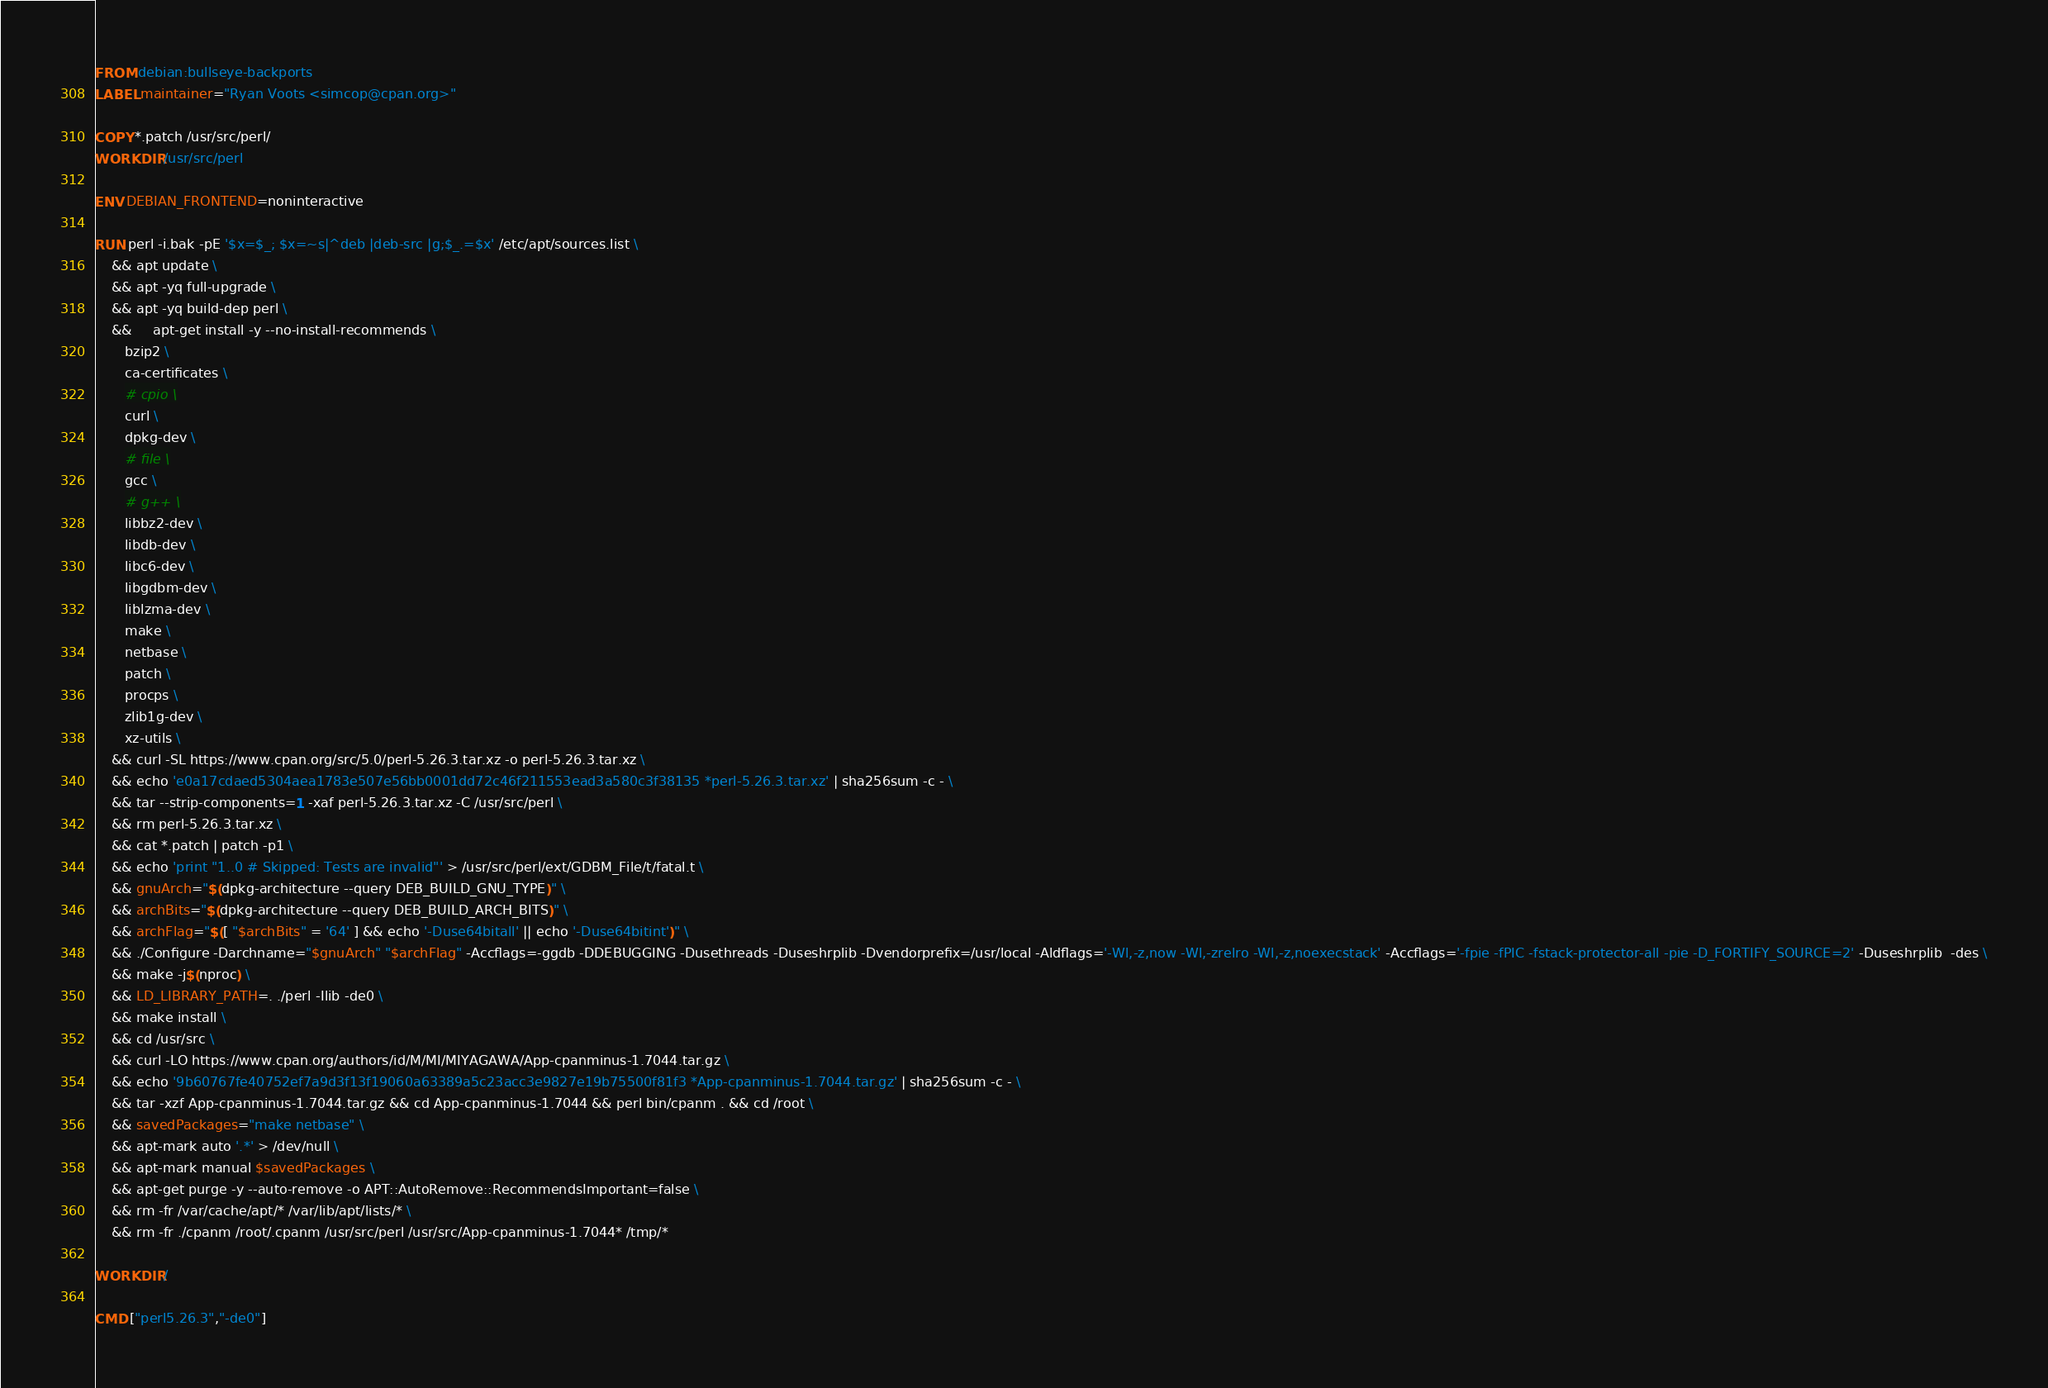<code> <loc_0><loc_0><loc_500><loc_500><_Dockerfile_>FROM debian:bullseye-backports
LABEL maintainer="Ryan Voots <simcop@cpan.org>"

COPY *.patch /usr/src/perl/
WORKDIR /usr/src/perl

ENV DEBIAN_FRONTEND=noninteractive

RUN perl -i.bak -pE '$x=$_; $x=~s|^deb |deb-src |g;$_.=$x' /etc/apt/sources.list \
    && apt update \
    && apt -yq full-upgrade \
    && apt -yq build-dep perl \
    &&     apt-get install -y --no-install-recommends \
       bzip2 \
       ca-certificates \
       # cpio \
       curl \
       dpkg-dev \
       # file \
       gcc \
       # g++ \
       libbz2-dev \
       libdb-dev \
       libc6-dev \
       libgdbm-dev \
       liblzma-dev \
       make \
       netbase \
       patch \
       procps \
       zlib1g-dev \
       xz-utils \
    && curl -SL https://www.cpan.org/src/5.0/perl-5.26.3.tar.xz -o perl-5.26.3.tar.xz \
    && echo 'e0a17cdaed5304aea1783e507e56bb0001dd72c46f211553ead3a580c3f38135 *perl-5.26.3.tar.xz' | sha256sum -c - \
    && tar --strip-components=1 -xaf perl-5.26.3.tar.xz -C /usr/src/perl \
    && rm perl-5.26.3.tar.xz \
    && cat *.patch | patch -p1 \
    && echo 'print "1..0 # Skipped: Tests are invalid"' > /usr/src/perl/ext/GDBM_File/t/fatal.t \
    && gnuArch="$(dpkg-architecture --query DEB_BUILD_GNU_TYPE)" \
    && archBits="$(dpkg-architecture --query DEB_BUILD_ARCH_BITS)" \
    && archFlag="$([ "$archBits" = '64' ] && echo '-Duse64bitall' || echo '-Duse64bitint')" \
    && ./Configure -Darchname="$gnuArch" "$archFlag" -Accflags=-ggdb -DDEBUGGING -Dusethreads -Duseshrplib -Dvendorprefix=/usr/local -Aldflags='-Wl,-z,now -Wl,-zrelro -Wl,-z,noexecstack' -Accflags='-fpie -fPIC -fstack-protector-all -pie -D_FORTIFY_SOURCE=2' -Duseshrplib  -des \
    && make -j$(nproc) \
    && LD_LIBRARY_PATH=. ./perl -Ilib -de0 \
    && make install \
    && cd /usr/src \
    && curl -LO https://www.cpan.org/authors/id/M/MI/MIYAGAWA/App-cpanminus-1.7044.tar.gz \
    && echo '9b60767fe40752ef7a9d3f13f19060a63389a5c23acc3e9827e19b75500f81f3 *App-cpanminus-1.7044.tar.gz' | sha256sum -c - \
    && tar -xzf App-cpanminus-1.7044.tar.gz && cd App-cpanminus-1.7044 && perl bin/cpanm . && cd /root \
    && savedPackages="make netbase" \
    && apt-mark auto '.*' > /dev/null \
    && apt-mark manual $savedPackages \
    && apt-get purge -y --auto-remove -o APT::AutoRemove::RecommendsImportant=false \
    && rm -fr /var/cache/apt/* /var/lib/apt/lists/* \
    && rm -fr ./cpanm /root/.cpanm /usr/src/perl /usr/src/App-cpanminus-1.7044* /tmp/*

WORKDIR /

CMD ["perl5.26.3","-de0"]
</code> 